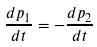<formula> <loc_0><loc_0><loc_500><loc_500>\frac { d p _ { 1 } } { d t } = - \frac { d p _ { 2 } } { d t }</formula> 